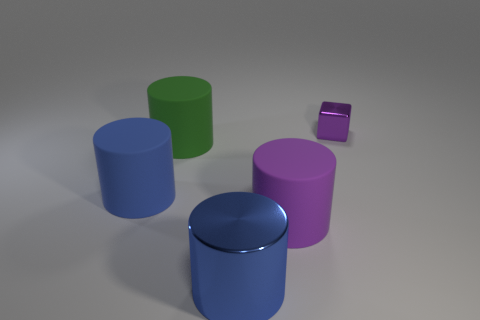Subtract all metal cylinders. How many cylinders are left? 3 Add 3 green cylinders. How many objects exist? 8 Subtract all green cylinders. How many cylinders are left? 3 Subtract all cubes. How many objects are left? 4 Subtract 1 cylinders. How many cylinders are left? 3 Subtract all purple blocks. How many gray cylinders are left? 0 Add 5 big green cylinders. How many big green cylinders exist? 6 Subtract 0 gray cylinders. How many objects are left? 5 Subtract all cyan blocks. Subtract all blue spheres. How many blocks are left? 1 Subtract all red matte things. Subtract all blue cylinders. How many objects are left? 3 